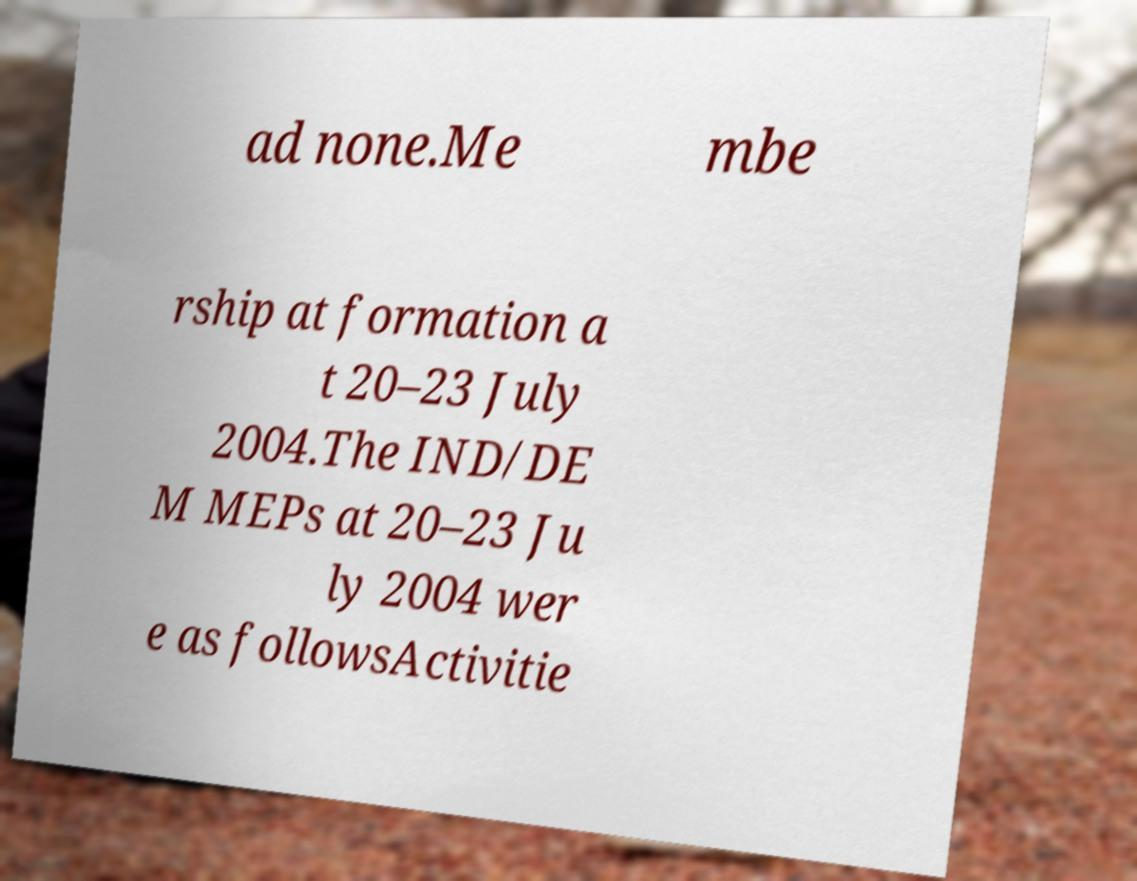Could you assist in decoding the text presented in this image and type it out clearly? ad none.Me mbe rship at formation a t 20–23 July 2004.The IND/DE M MEPs at 20–23 Ju ly 2004 wer e as followsActivitie 